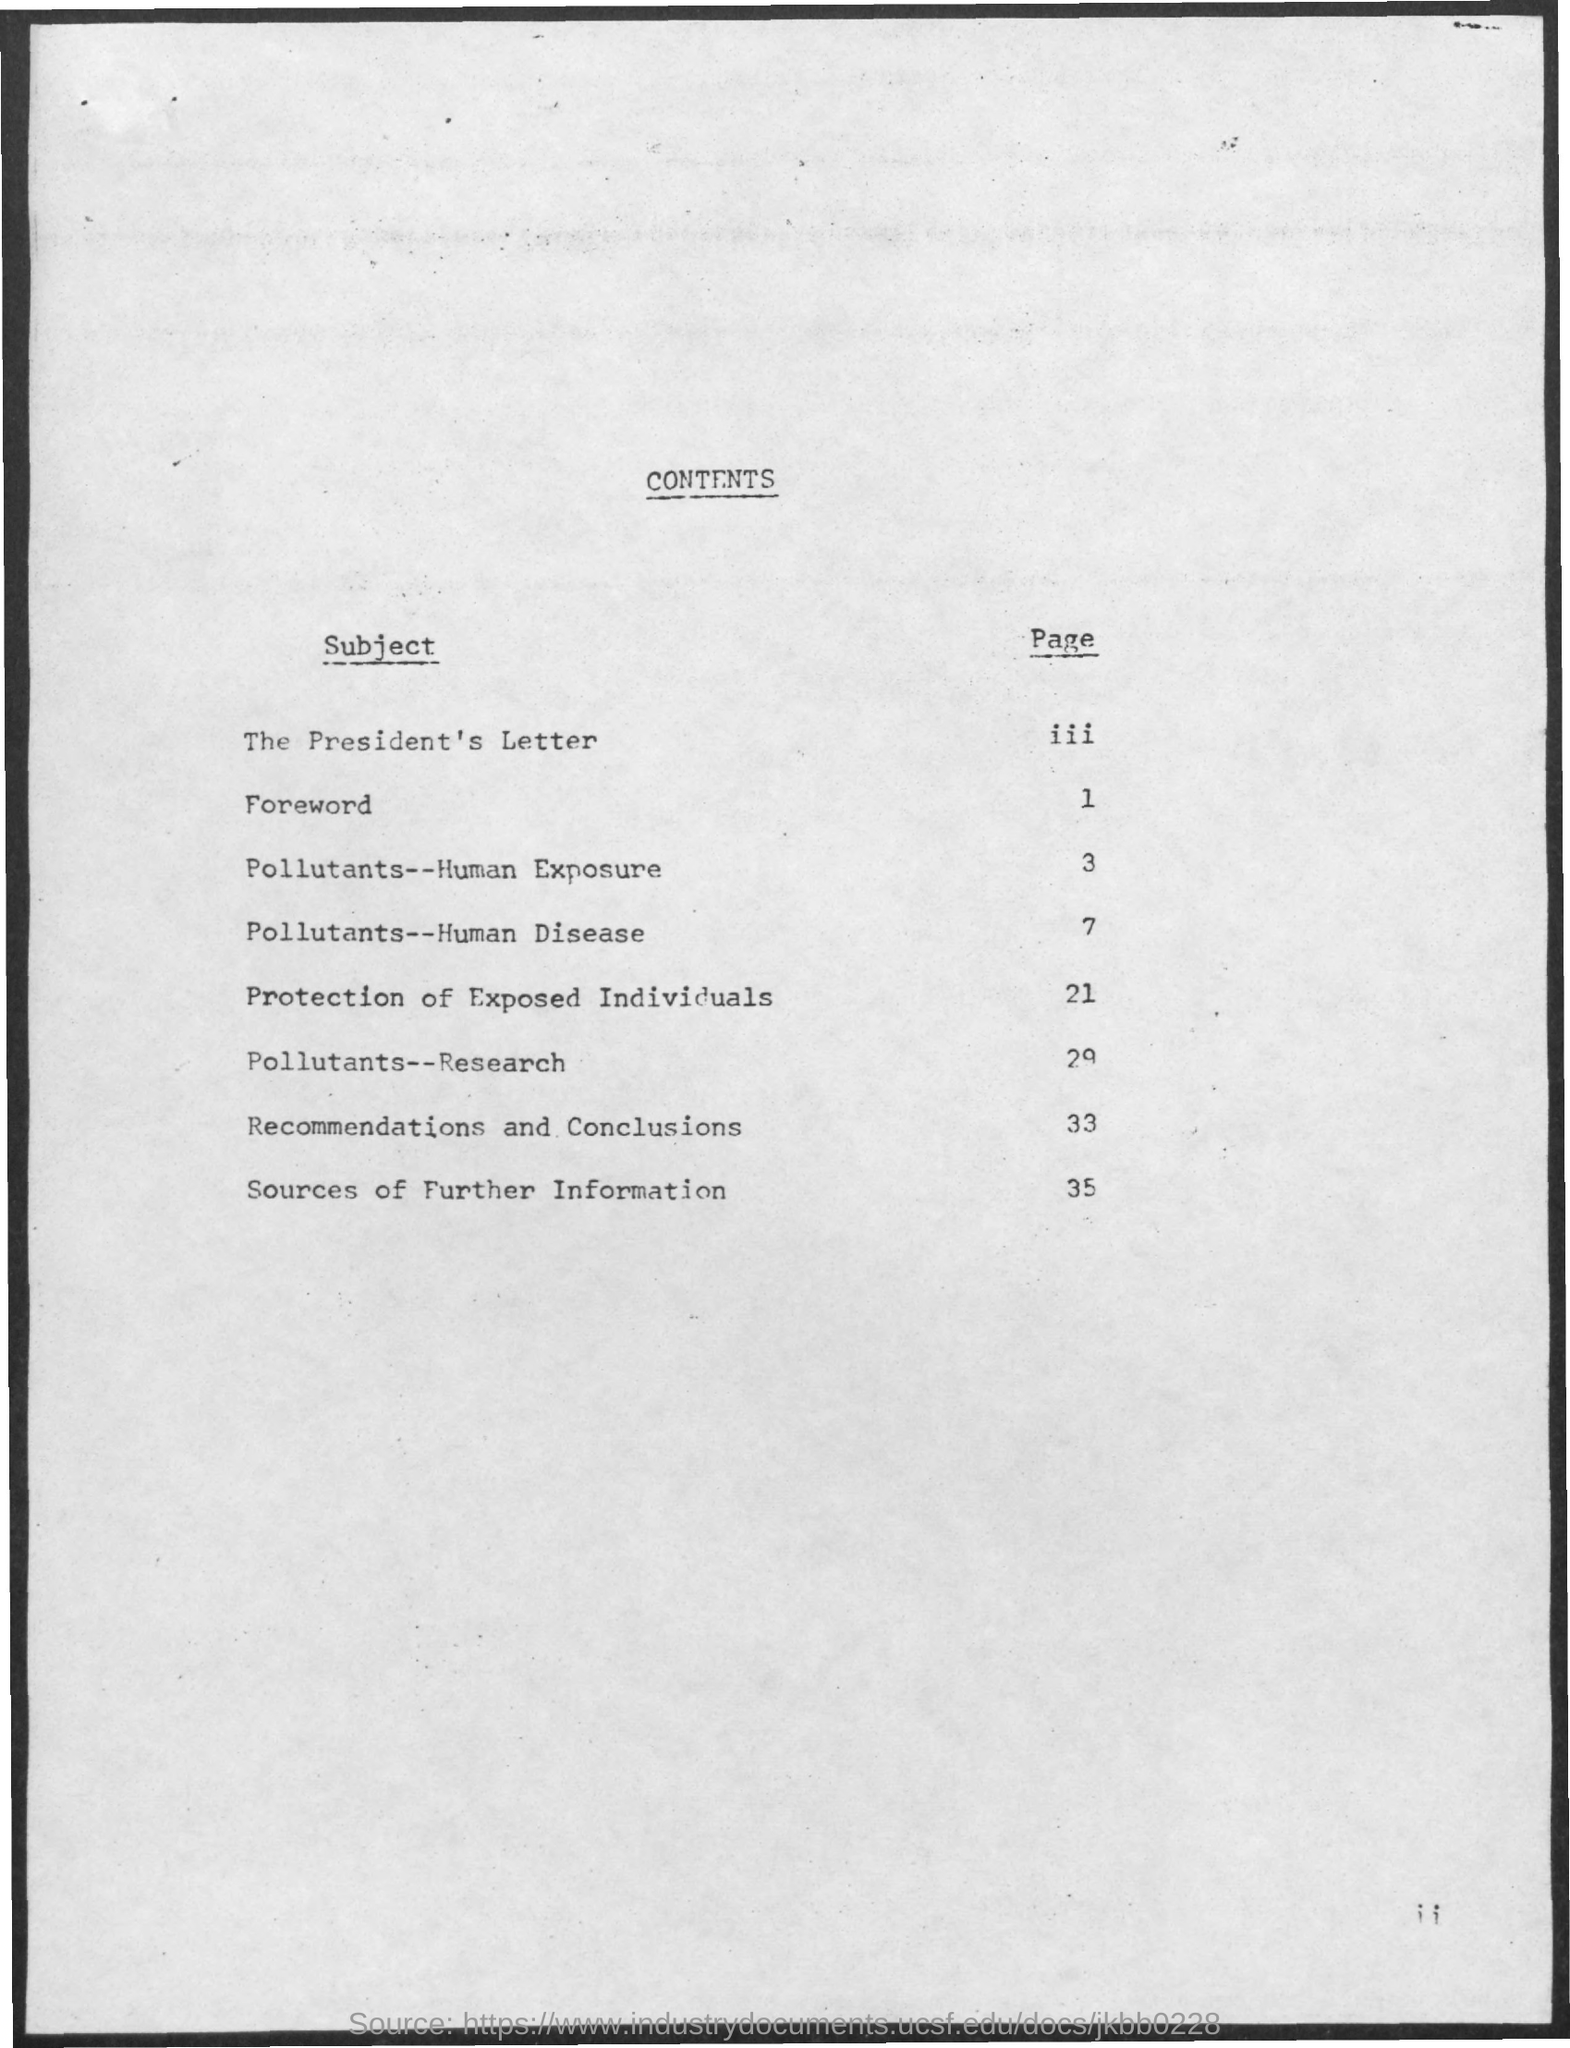Can you tell me more about the overall theme of this document based on the table of contents? The document appears to focus on environmental health, specifically the exposure to pollutants, how they affect human health and disease, and measures for protecting individuals. Research findings and recommendations are likely discussed, leading to further sources of information. 